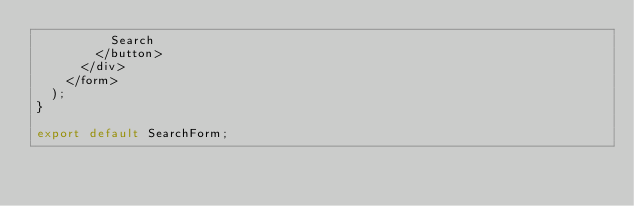Convert code to text. <code><loc_0><loc_0><loc_500><loc_500><_JavaScript_>          Search
        </button>
      </div>
    </form>
  );
}

export default SearchForm;
</code> 